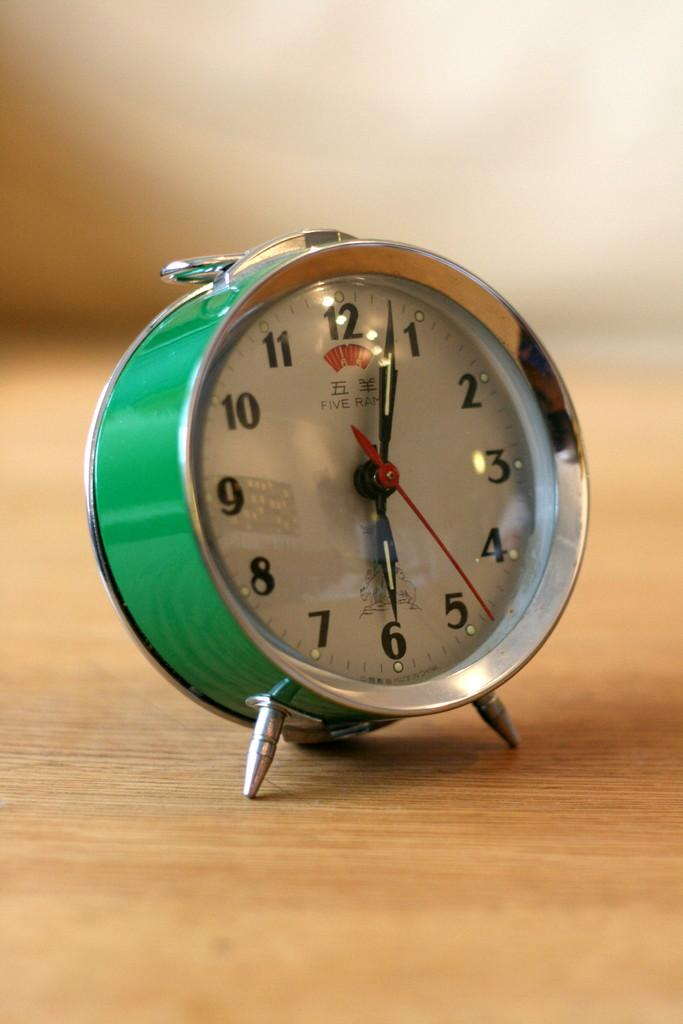<image>
Create a compact narrative representing the image presented. The alarm clock is from the company called Five Ram 